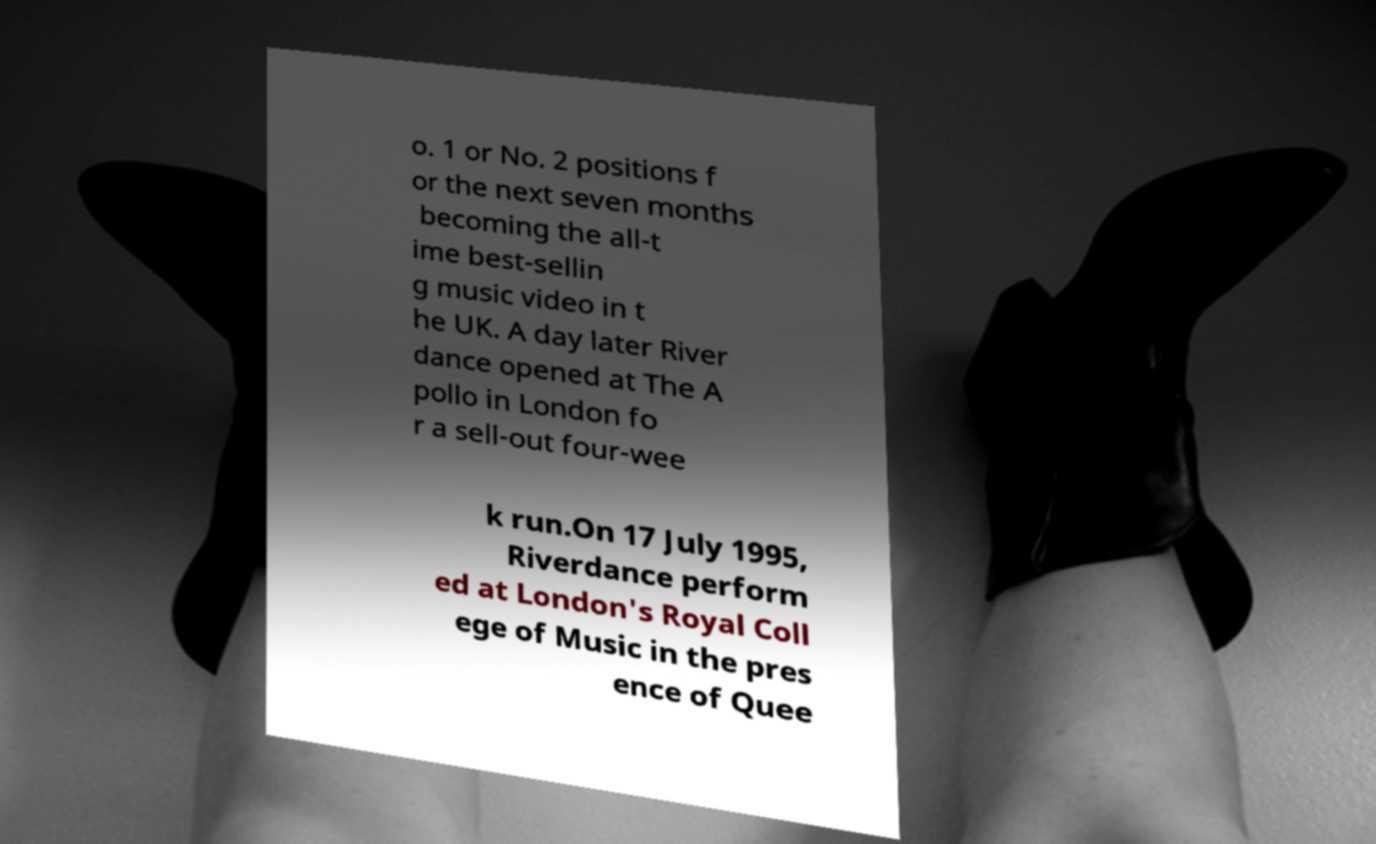Please identify and transcribe the text found in this image. o. 1 or No. 2 positions f or the next seven months becoming the all-t ime best-sellin g music video in t he UK. A day later River dance opened at The A pollo in London fo r a sell-out four-wee k run.On 17 July 1995, Riverdance perform ed at London's Royal Coll ege of Music in the pres ence of Quee 